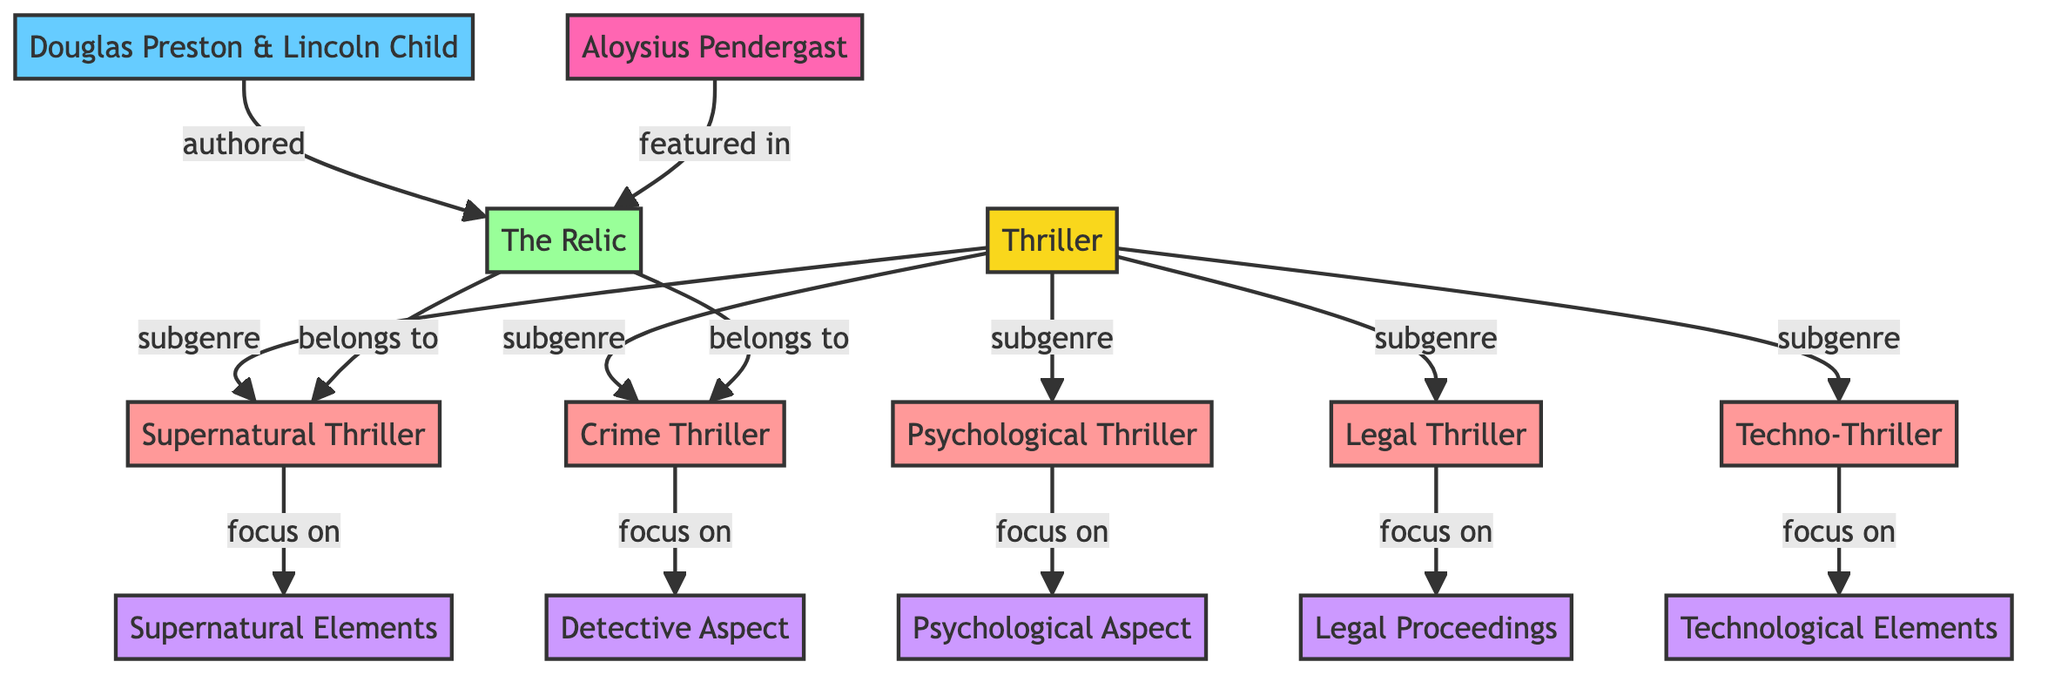What are the two main authors associated with the node "Douglas Preston & Lincoln Child"? The node "Douglas Preston & Lincoln Child" directly connects to the book "The Relic," indicating that this duo is known for writing this work. There are no other authors mentioned nearby.
Answer: Douglas Preston & Lincoln Child How many subgenres are categorized under "Thriller"? The node "Thriller" has five edges pointing to the subgenres: "Psychological Thriller," "Crime Thriller," "Legal Thriller," "Supernatural Thriller," and "Techno-Thriller." Counting these edges gives the total number of subgenres.
Answer: 5 Which node focuses on Psychological Aspects? The node "Psychological Thriller" has an edge that points to "Psychological Aspect," signifying that it focuses on psychological themes within the thriller genre.
Answer: Psychological Aspect What is the relationship between "The Relic" and "Crime Thriller"? The edge connecting "The Relic" to "Crime Thriller" indicates a belonging relationship. Specifically, "The Relic" is categorized as part of the crime thriller subgenre.
Answer: belongs to How many edges are connected to the "Legal Thriller" node? The "Legal Thriller" node is connected by one edge to "Law Aspect," which shows that the legal thriller genre specifically focuses on legal themes. The number of edges gives the count of direct connections.
Answer: 1 Which character is featured in "The Relic"? The node "Pendergast" has a direct connection to "The Relic," indicating that this character appears in that book. This is shown with the "featured in" relationship.
Answer: Aloysius Pendergast What type of thriller focuses on technological elements? The "Techno-Thriller" node has a direct link to "Tech Aspect," indicating that techno-thrillers are characterized by their emphasis on technology in the narrative.
Answer: Technological Elements What type of aspect does "Supernatural Thriller" focus on? The "Supernatural Thriller" node is connected to "Supernatural Aspect," indicating that this subgenre deals primarily with supernatural elements and themes in its stories.
Answer: Supernatural Elements How many unique types of thrillers are identified in this diagram? The "Thriller" node points to five unique subgenres: "Psychological Thriller," "Crime Thriller," "Legal Thriller," "Supernatural Thriller," and "Techno-Thriller." Therefore, counting these gives the total number of unique thriller types.
Answer: 5 